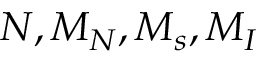Convert formula to latex. <formula><loc_0><loc_0><loc_500><loc_500>N , M _ { N } , M _ { s } , M _ { I }</formula> 